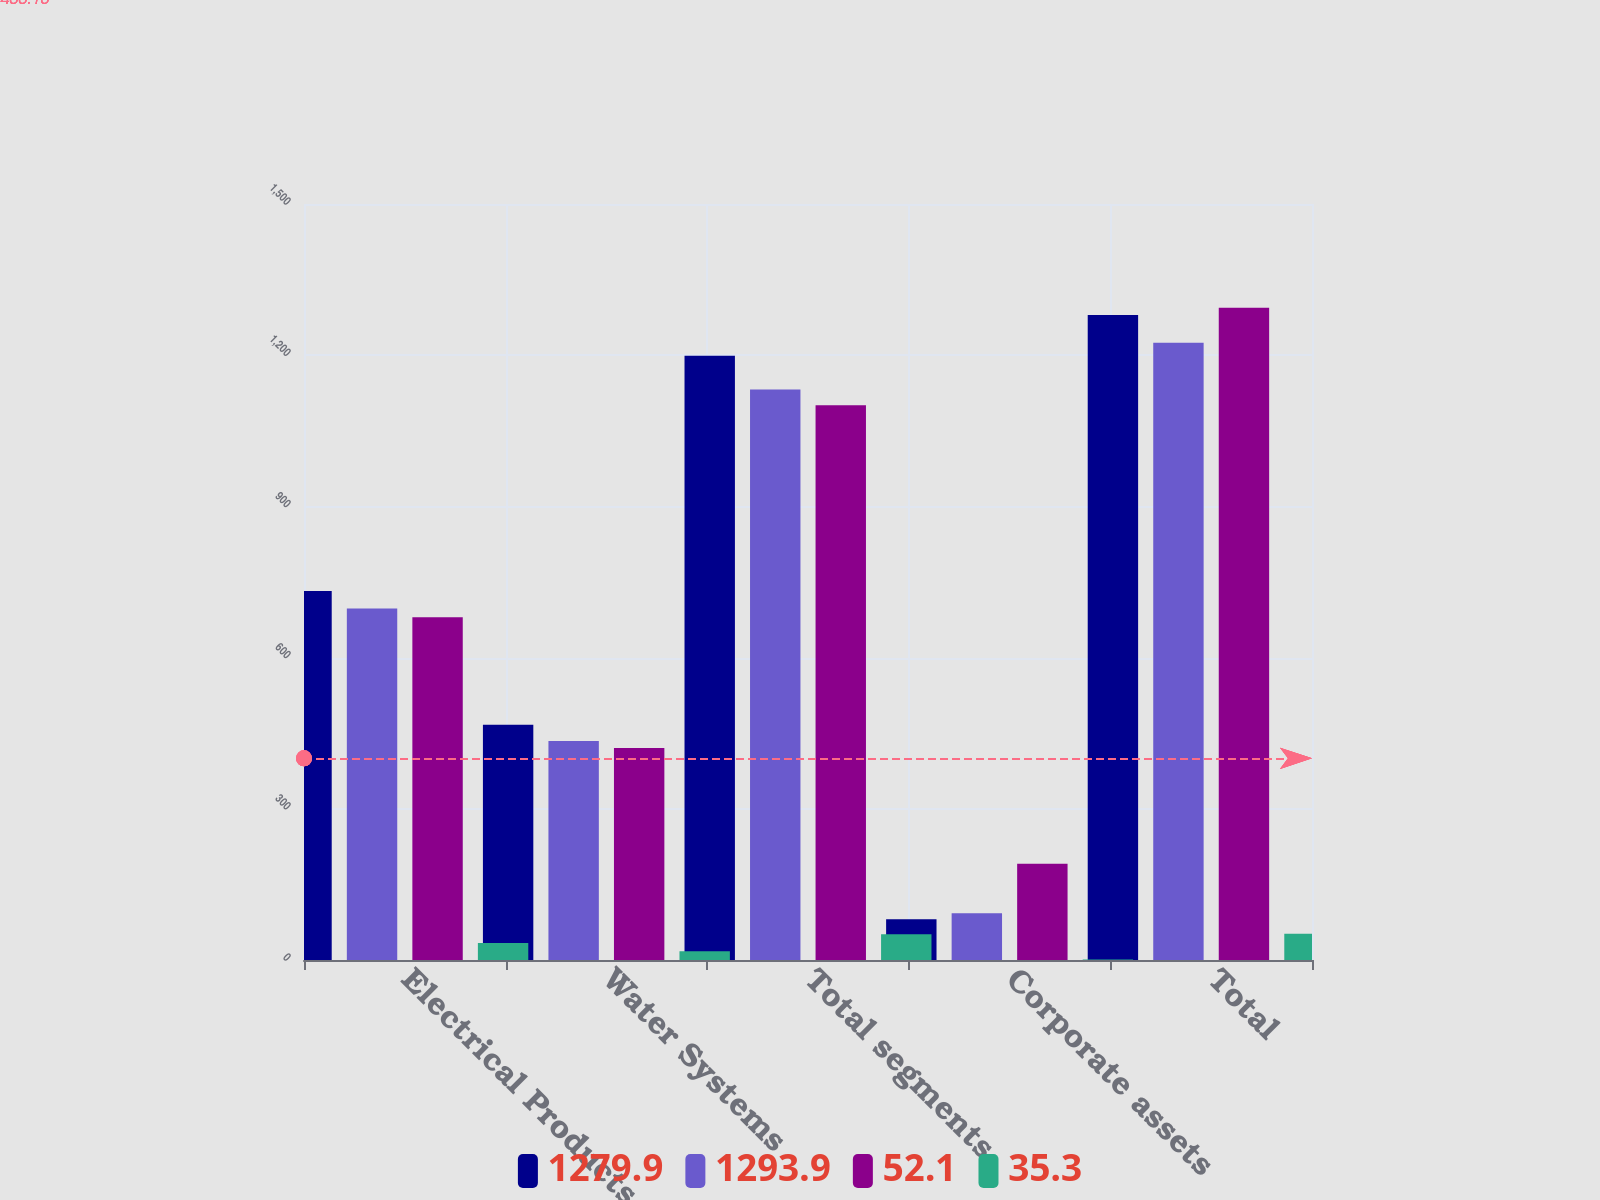Convert chart. <chart><loc_0><loc_0><loc_500><loc_500><stacked_bar_chart><ecel><fcel>Electrical Products<fcel>Water Systems<fcel>Total segments<fcel>Corporate assets<fcel>Total<nl><fcel>1279.9<fcel>732.1<fcel>466.8<fcel>1198.9<fcel>81<fcel>1279.9<nl><fcel>1293.9<fcel>697.4<fcel>434.7<fcel>1132.1<fcel>92.8<fcel>1224.9<nl><fcel>52.1<fcel>680.3<fcel>420.6<fcel>1100.9<fcel>191.2<fcel>1293.9<nl><fcel>35.3<fcel>33.7<fcel>17.6<fcel>51.3<fcel>0.8<fcel>52.1<nl></chart> 